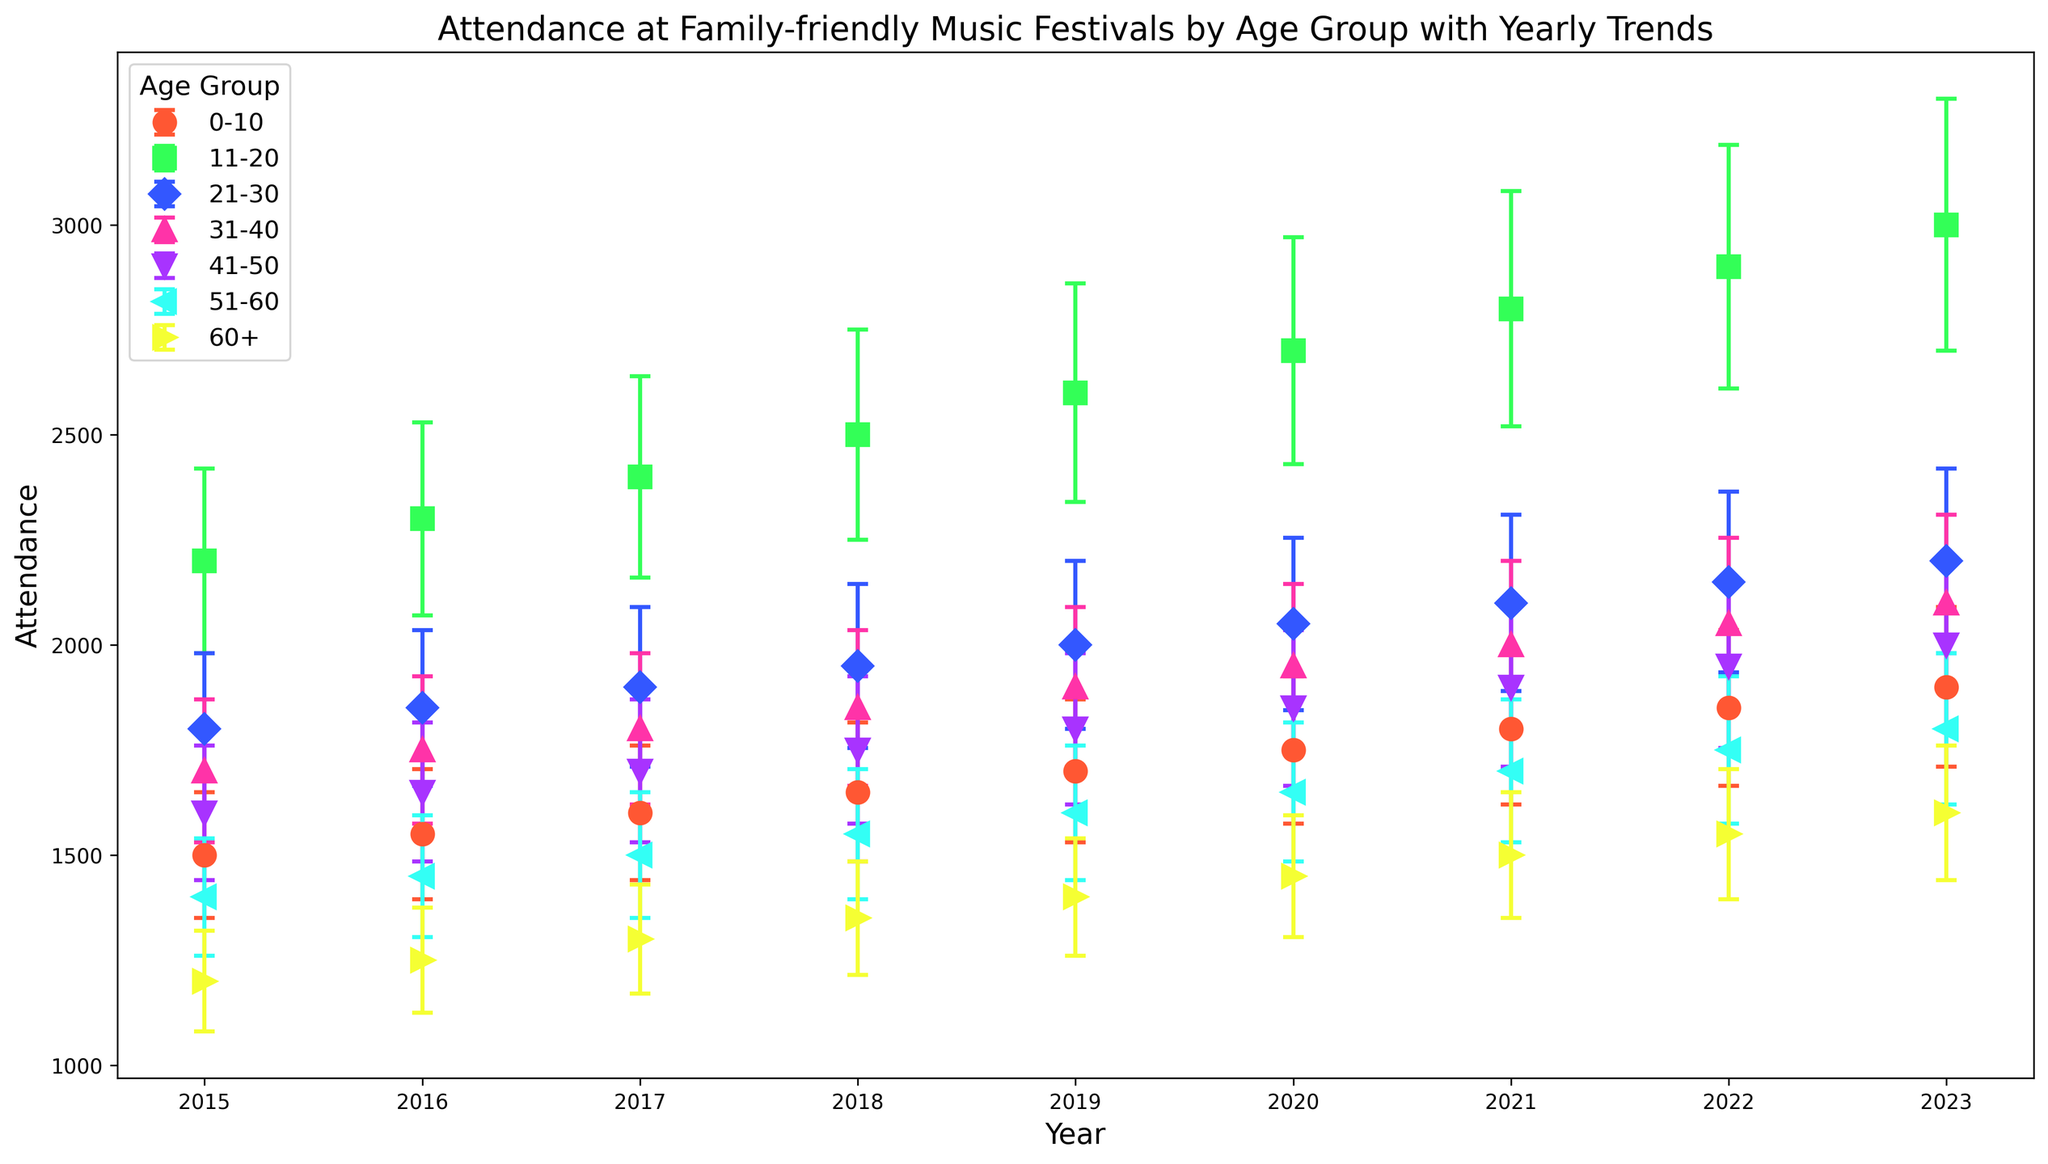What's the attendance trend for the 0-10 age group from 2015 to 2023? Look at the plot and observe the markers for the 0-10 age group. Notice that the attendance trend for this age group shows a steady increase from 2015 to 2023.
Answer: Steady increase Which age group had the highest attendance in 2023? Observe the markers for each age group in the 2023 column. Notice that the 11-20 age group has the highest marker, indicating the highest attendance.
Answer: 11-20 How does the attendance for the 60+ age group in 2020 compare to 2015? Find the markers for the 60+ age group in the years 2015 and 2020. Compare their heights: the attendance in 2020 (1450) is higher than in 2015 (1200).
Answer: 2020 is higher than 2015 What is the average attendance for the 51-60 age group over the years presented? Add the attendance values for the 51-60 age group from 2015 to 2023 and divide by 9: (1400 + 1450 + 1500 + 1550 + 1600 + 1650 + 1700 + 1750 + 1800) / 9 = 1533
Answer: 1533 Which age group showed the most significant increase in attendance from 2015 to 2023? Calculate the difference in attendance from 2015 to 2023 for each age group. The 11-20 age group shows the largest increase: 3000 (2023) - 2200 (2015) = 800.
Answer: 11-20 Does the 21-30 age group show a consistent trend in attendance from 2015 to 2023? Observe the markers for the 21-30 age group across the years. Notice that the attendance steadily increases each year, indicating a consistent trend.
Answer: Yes What is the total attendance for the 31-40 age group across all years? Sum the attendance values for the 31-40 age group from 2015 to 2023: 1700 + 1750 + 1800 + 1850 + 1900 + 1950 + 2000 + 2050 + 2100 = 17100
Answer: 17100 Between the years 2018 and 2022, which age group saw the least change in attendance? Calculate the difference in attendance for each age group between 2018 and 2022 and find the smallest change. The 31-40 age group has the least change: 2050 - 1850 = 200.
Answer: 31-40 How does the error bar for the 60+ age group in 2021 compare to that in 2015? Examine the lengths of the error bars for the 60+ age group in 2021 and 2015. Both error bars are 150 and 120 units respectively. So, the error in 2021 is greater.
Answer: 2021 is greater 